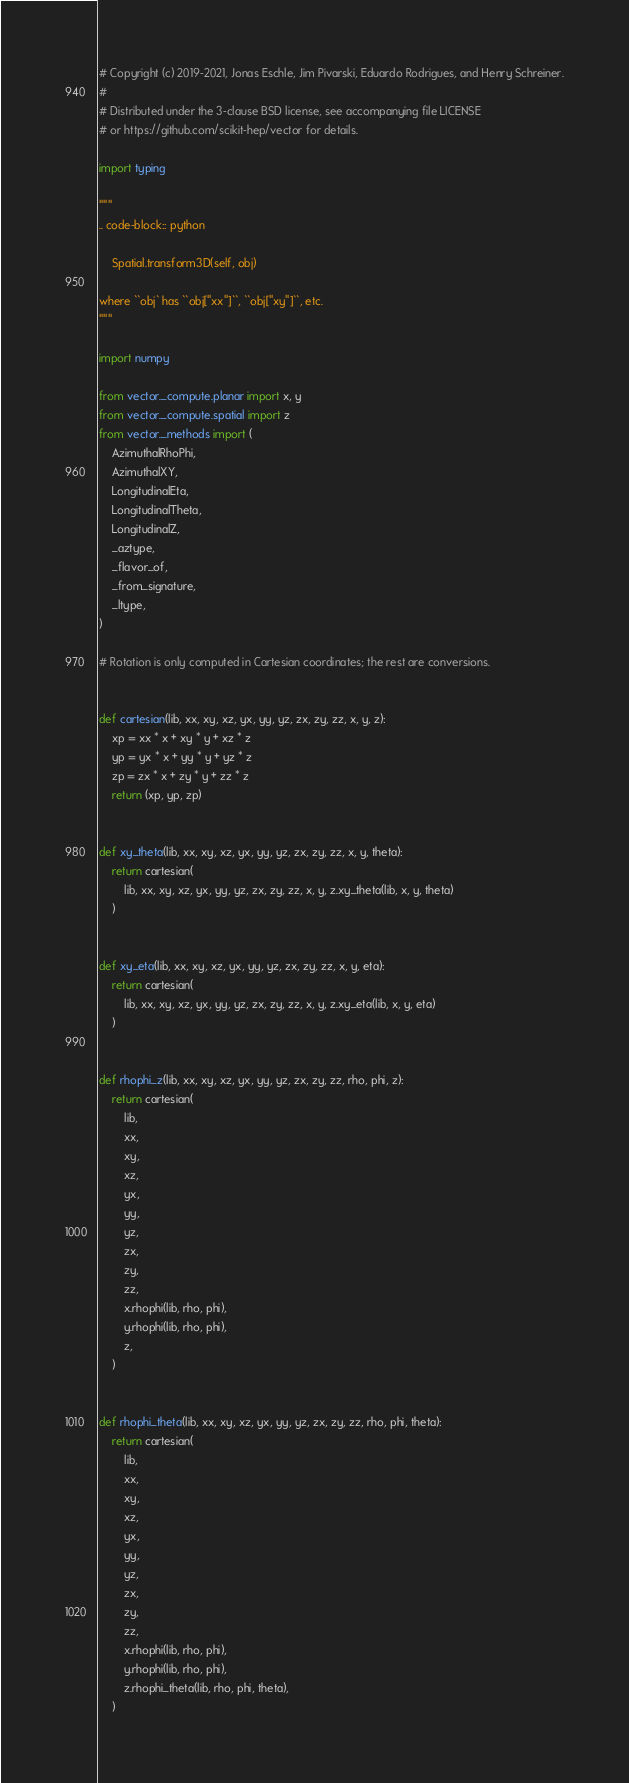Convert code to text. <code><loc_0><loc_0><loc_500><loc_500><_Python_># Copyright (c) 2019-2021, Jonas Eschle, Jim Pivarski, Eduardo Rodrigues, and Henry Schreiner.
#
# Distributed under the 3-clause BSD license, see accompanying file LICENSE
# or https://github.com/scikit-hep/vector for details.

import typing

"""
.. code-block:: python

    Spatial.transform3D(self, obj)

where ``obj` has ``obj["xx"]``, ``obj["xy"]``, etc.
"""

import numpy

from vector._compute.planar import x, y
from vector._compute.spatial import z
from vector._methods import (
    AzimuthalRhoPhi,
    AzimuthalXY,
    LongitudinalEta,
    LongitudinalTheta,
    LongitudinalZ,
    _aztype,
    _flavor_of,
    _from_signature,
    _ltype,
)

# Rotation is only computed in Cartesian coordinates; the rest are conversions.


def cartesian(lib, xx, xy, xz, yx, yy, yz, zx, zy, zz, x, y, z):
    xp = xx * x + xy * y + xz * z
    yp = yx * x + yy * y + yz * z
    zp = zx * x + zy * y + zz * z
    return (xp, yp, zp)


def xy_theta(lib, xx, xy, xz, yx, yy, yz, zx, zy, zz, x, y, theta):
    return cartesian(
        lib, xx, xy, xz, yx, yy, yz, zx, zy, zz, x, y, z.xy_theta(lib, x, y, theta)
    )


def xy_eta(lib, xx, xy, xz, yx, yy, yz, zx, zy, zz, x, y, eta):
    return cartesian(
        lib, xx, xy, xz, yx, yy, yz, zx, zy, zz, x, y, z.xy_eta(lib, x, y, eta)
    )


def rhophi_z(lib, xx, xy, xz, yx, yy, yz, zx, zy, zz, rho, phi, z):
    return cartesian(
        lib,
        xx,
        xy,
        xz,
        yx,
        yy,
        yz,
        zx,
        zy,
        zz,
        x.rhophi(lib, rho, phi),
        y.rhophi(lib, rho, phi),
        z,
    )


def rhophi_theta(lib, xx, xy, xz, yx, yy, yz, zx, zy, zz, rho, phi, theta):
    return cartesian(
        lib,
        xx,
        xy,
        xz,
        yx,
        yy,
        yz,
        zx,
        zy,
        zz,
        x.rhophi(lib, rho, phi),
        y.rhophi(lib, rho, phi),
        z.rhophi_theta(lib, rho, phi, theta),
    )

</code> 